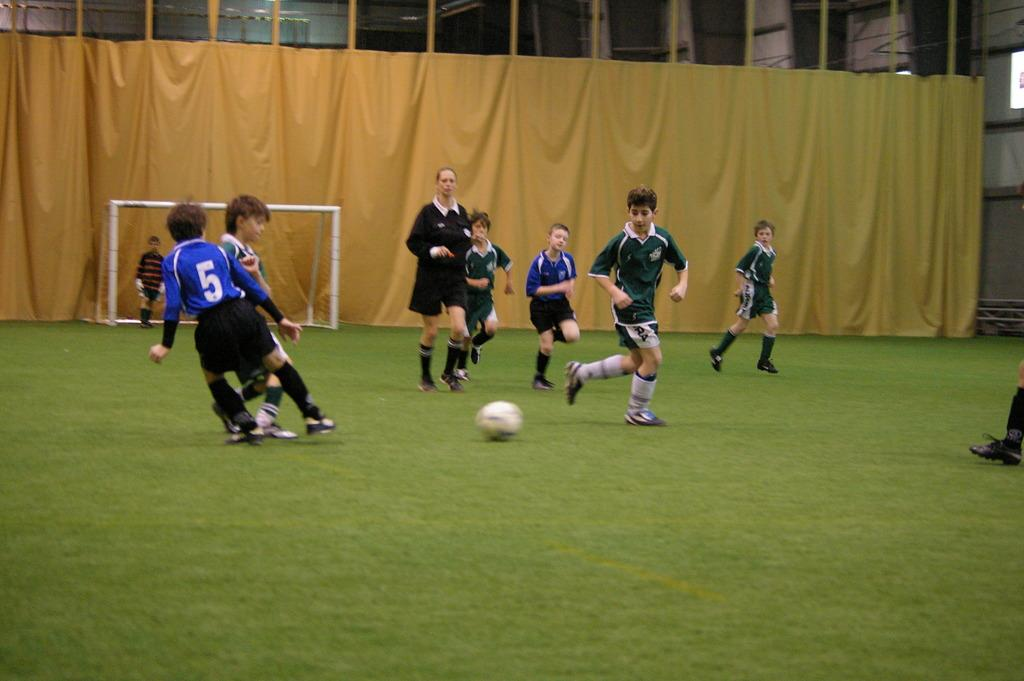What activity are the people in the image engaged in? The people in the image are playing in a football ground. Can you describe the background of the image? There is a curtain in the background of the image. What type of camera is being used by the people playing football in the image? There is no camera visible in the image; the people are playing football without any camera equipment. 